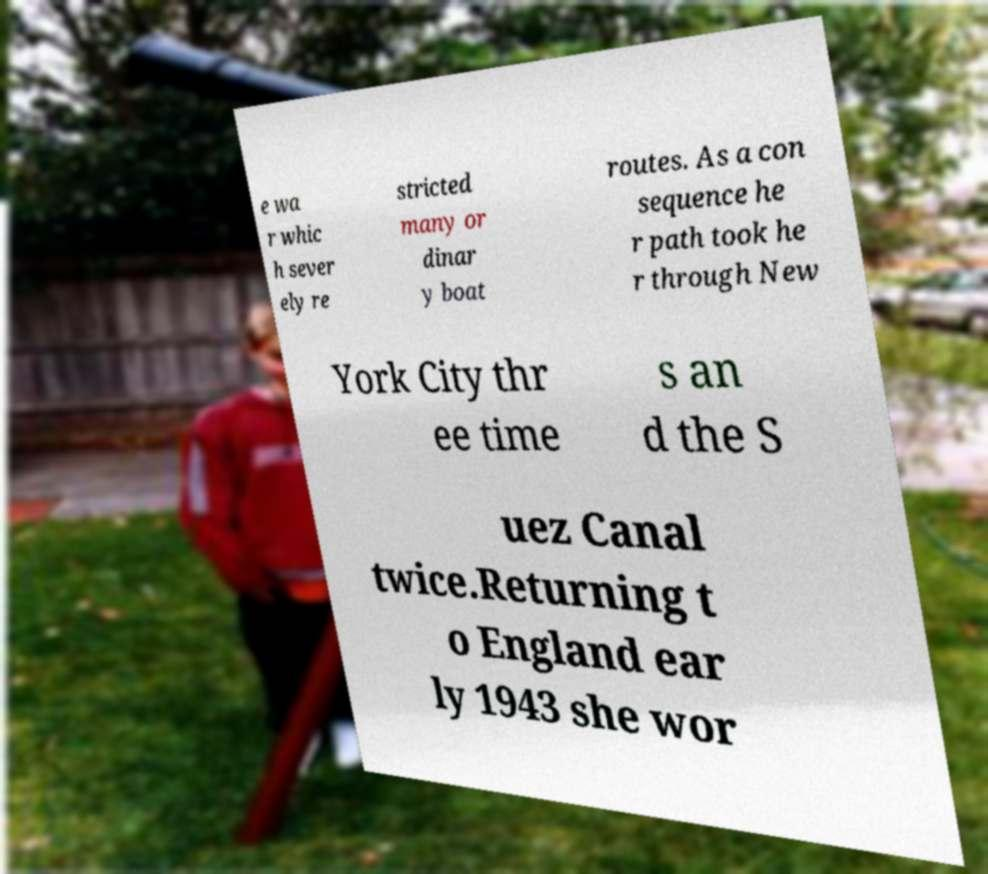I need the written content from this picture converted into text. Can you do that? e wa r whic h sever ely re stricted many or dinar y boat routes. As a con sequence he r path took he r through New York City thr ee time s an d the S uez Canal twice.Returning t o England ear ly 1943 she wor 